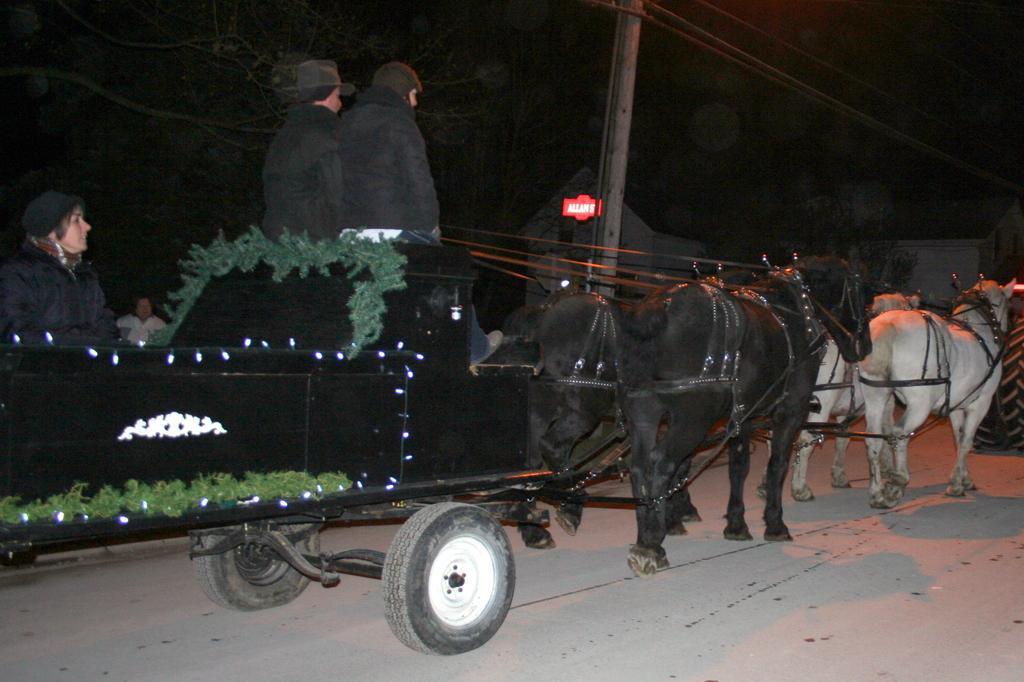Could you give a brief overview of what you see in this image? In this image I can see an animal cart which is black in color is tied to the horses which are black and white in color. I can see few persons wearing black color dresses in the cart. In the background I can see a pole, few buildings, a tree and the dark sky. 